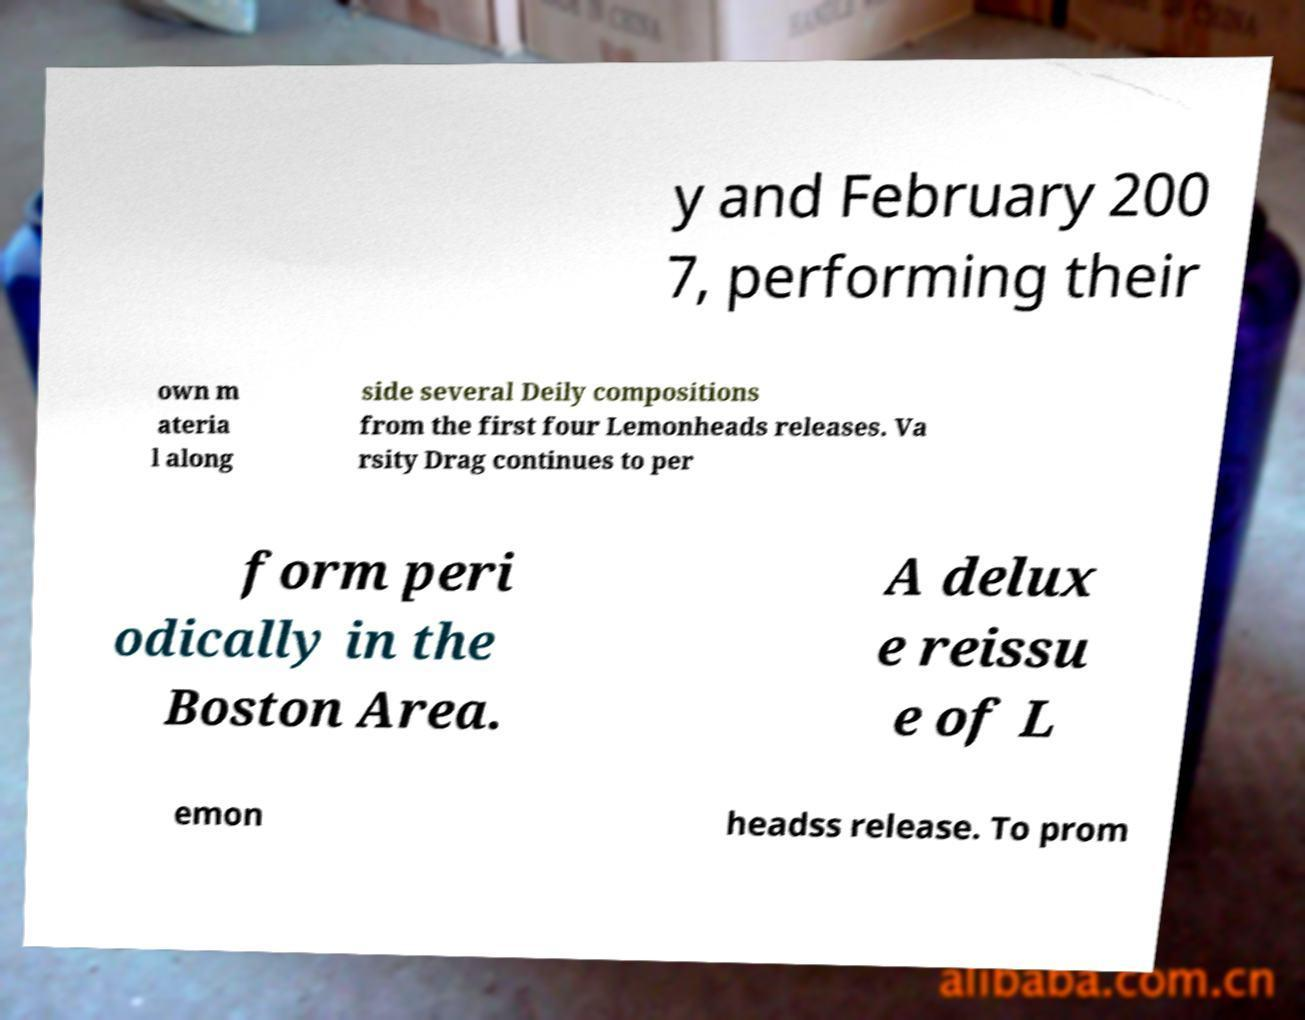Please read and relay the text visible in this image. What does it say? y and February 200 7, performing their own m ateria l along side several Deily compositions from the first four Lemonheads releases. Va rsity Drag continues to per form peri odically in the Boston Area. A delux e reissu e of L emon headss release. To prom 